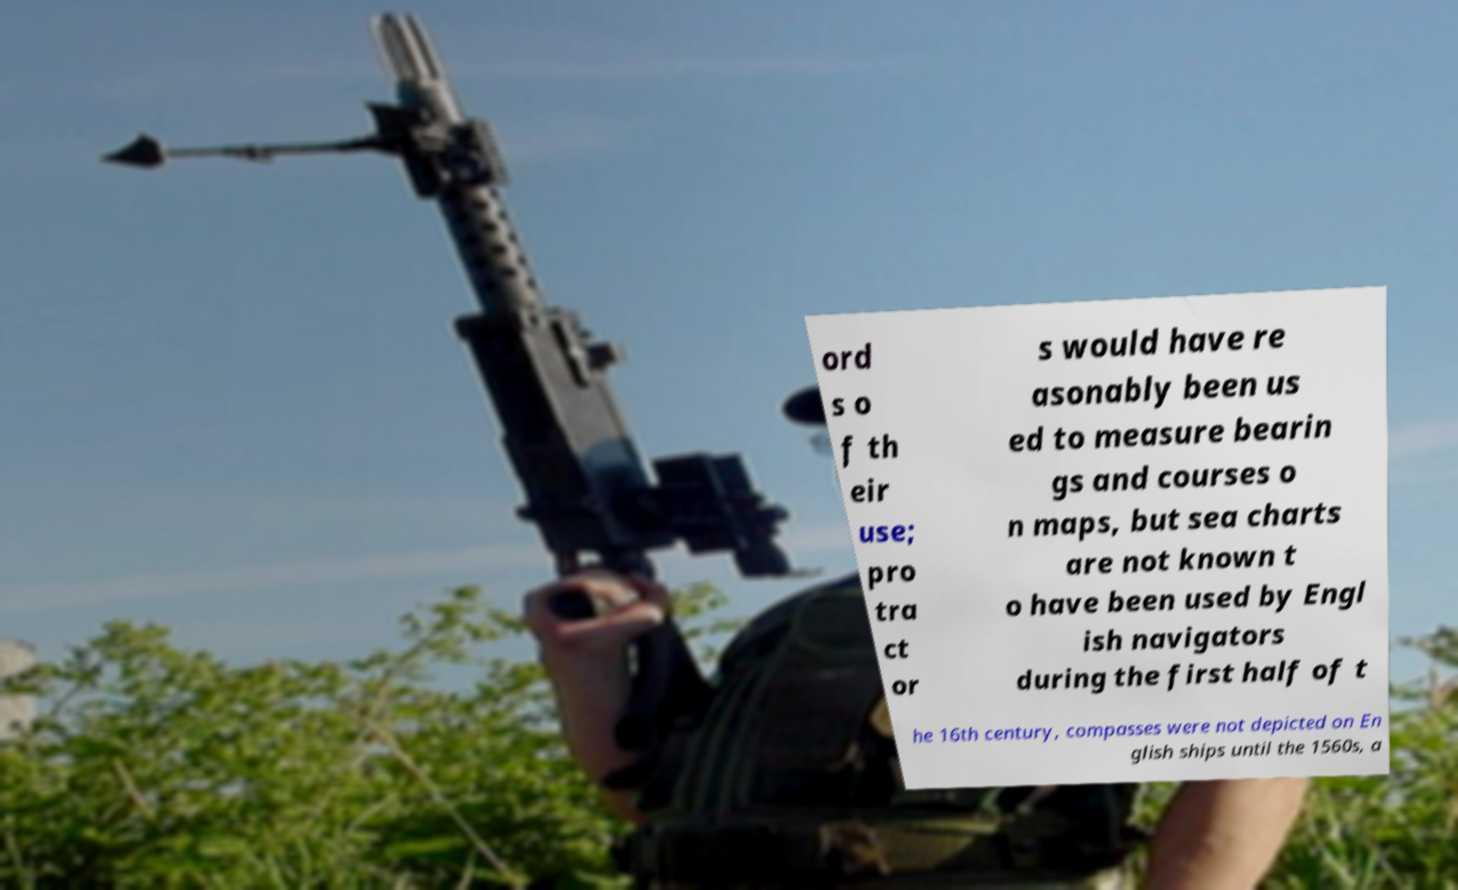Can you read and provide the text displayed in the image?This photo seems to have some interesting text. Can you extract and type it out for me? ord s o f th eir use; pro tra ct or s would have re asonably been us ed to measure bearin gs and courses o n maps, but sea charts are not known t o have been used by Engl ish navigators during the first half of t he 16th century, compasses were not depicted on En glish ships until the 1560s, a 